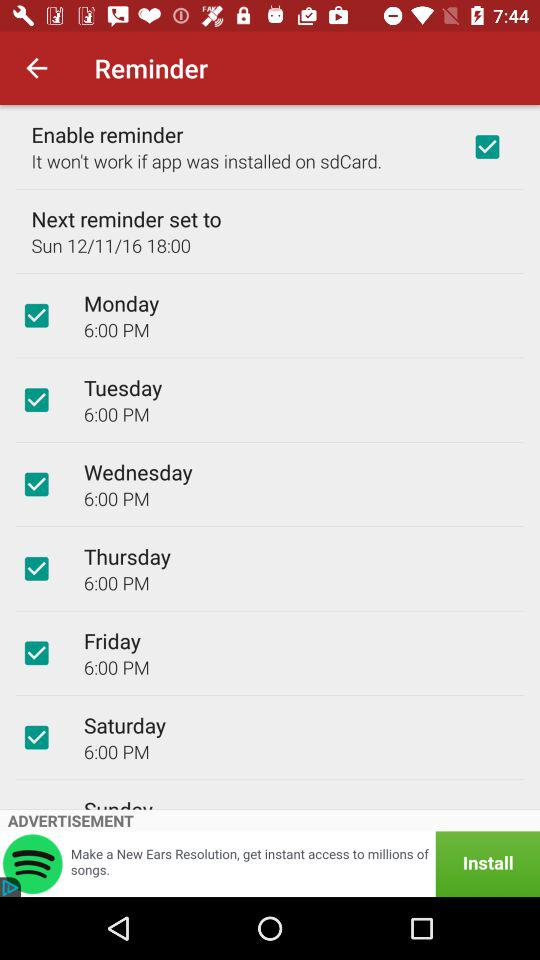For which days of the week is the reminder set? The reminder is set for Sunday, "Monday", "Tuesday", "Wednesday", "Thrusday", "Friday", and "Saturday". 